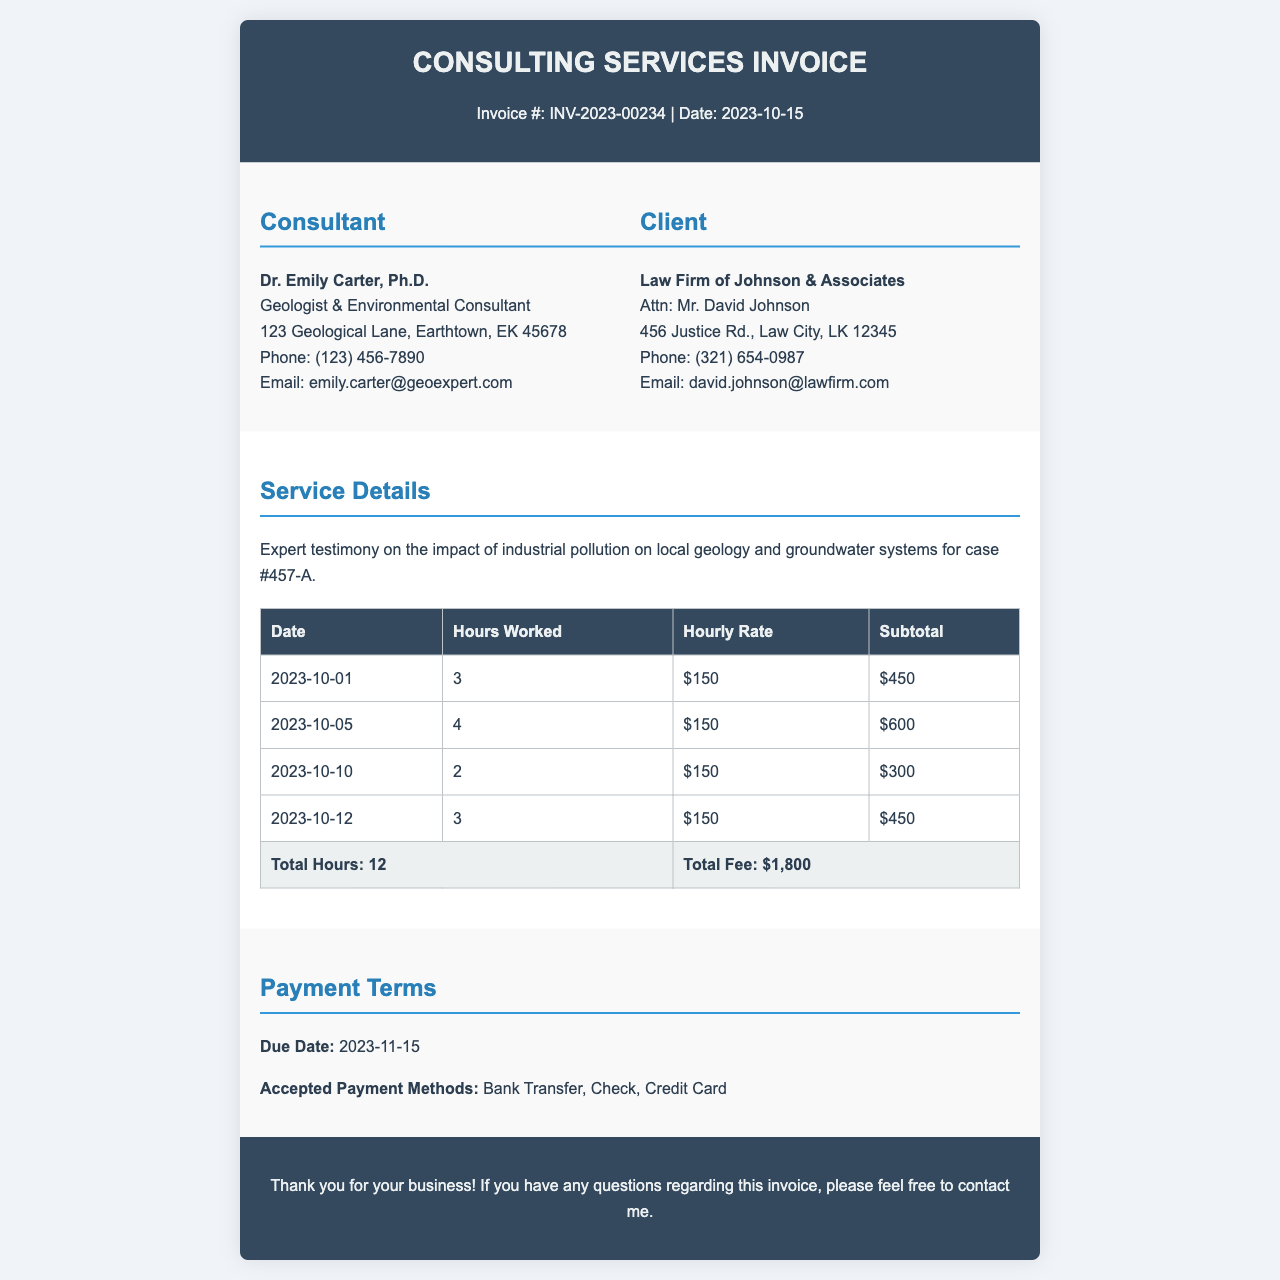What is the invoice number? The invoice number is clearly stated in the header of the document, which is INV-2023-00234.
Answer: INV-2023-00234 Who is the consultant? The document lists the consultant's name as Dr. Emily Carter, Ph.D.
Answer: Dr. Emily Carter, Ph.D What is the total fee for services provided? The total fee is highlighted in the table summarizing the services, which amounts to $1,800.
Answer: $1,800 How many total hours were worked? The total hours worked are summarized in the last row of the table, totaling 12 hours.
Answer: 12 What is the hourly rate for the consulting services? The hourly rate is stated in the table for each entry, which is consistently $150.
Answer: $150 What is the due date for the payment? The document specifies the due date for the payment in the payment terms section, which is 2023-11-15.
Answer: 2023-11-15 What service was provided? The service details section describes the service as expert testimony on the impact of industrial pollution.
Answer: Expert testimony on the impact of industrial pollution What payment methods are accepted? The accepted payment methods are listed in the payment terms section, which includes Bank Transfer, Check, and Credit Card.
Answer: Bank Transfer, Check, Credit Card How many days are there until the payment due date from the invoice date? The invoice date is 2023-10-15 and the due date is 2023-11-15, making it 31 days until payment is due.
Answer: 31 